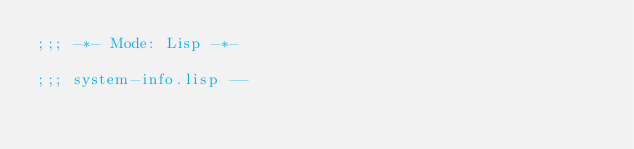<code> <loc_0><loc_0><loc_500><loc_500><_Lisp_>;;; -*- Mode: Lisp -*-

;;; system-info.lisp --</code> 